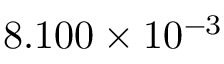Convert formula to latex. <formula><loc_0><loc_0><loc_500><loc_500>8 . 1 0 0 \times 1 0 ^ { - 3 }</formula> 